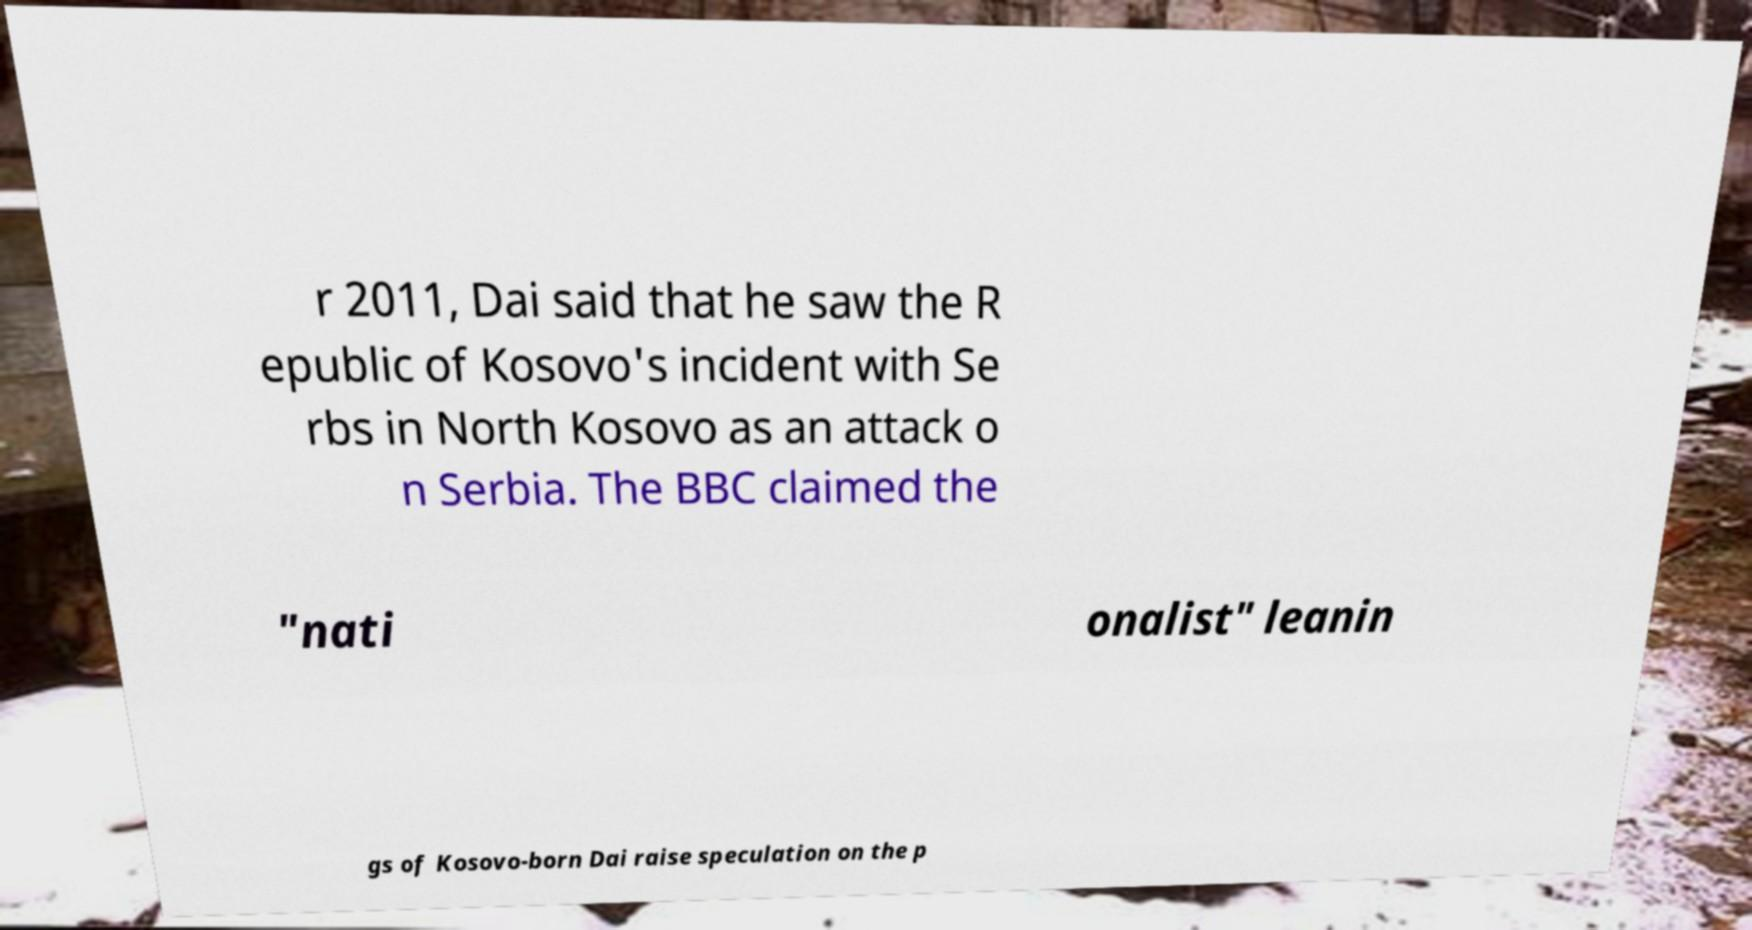Could you assist in decoding the text presented in this image and type it out clearly? r 2011, Dai said that he saw the R epublic of Kosovo's incident with Se rbs in North Kosovo as an attack o n Serbia. The BBC claimed the "nati onalist" leanin gs of Kosovo-born Dai raise speculation on the p 